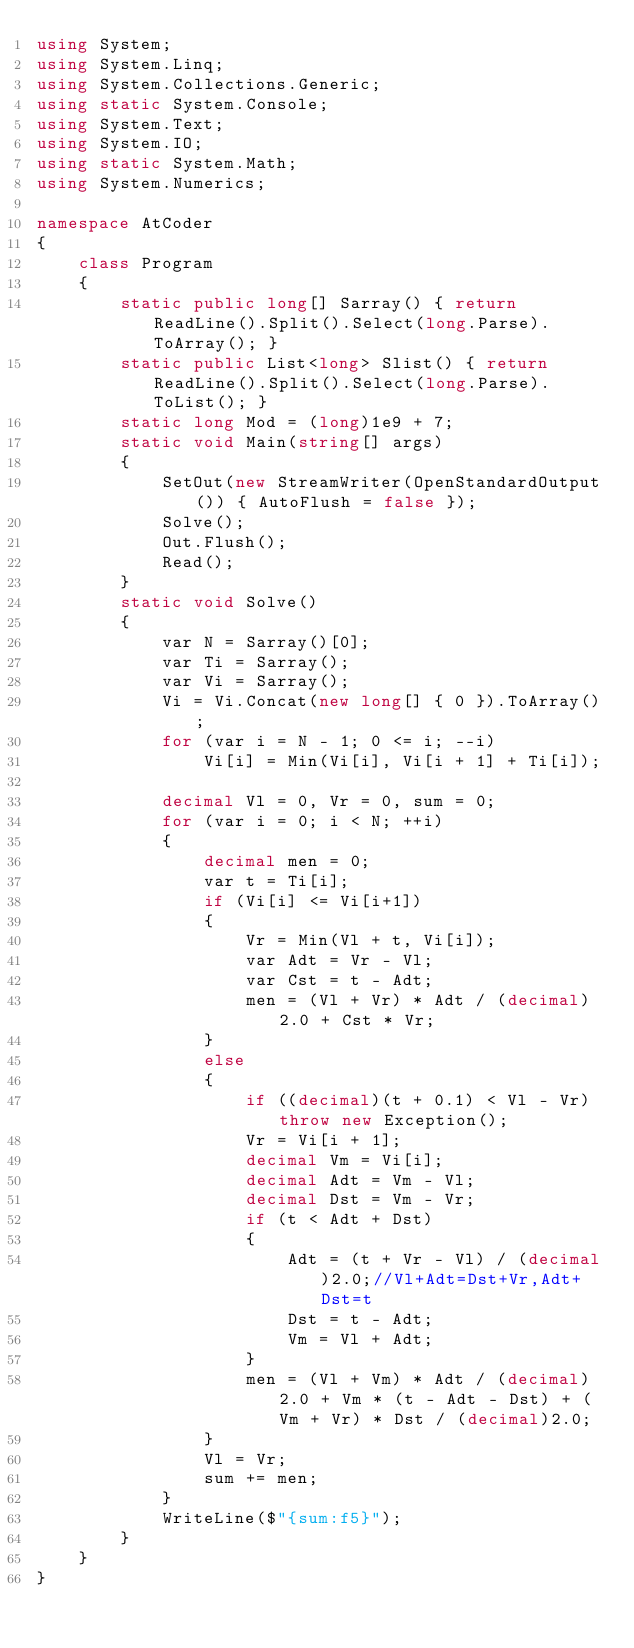<code> <loc_0><loc_0><loc_500><loc_500><_C#_>using System;
using System.Linq;
using System.Collections.Generic;
using static System.Console;
using System.Text;
using System.IO;
using static System.Math;
using System.Numerics;

namespace AtCoder
{
    class Program
    {
        static public long[] Sarray() { return ReadLine().Split().Select(long.Parse).ToArray(); }
        static public List<long> Slist() { return ReadLine().Split().Select(long.Parse).ToList(); }
        static long Mod = (long)1e9 + 7;
        static void Main(string[] args)
        {
            SetOut(new StreamWriter(OpenStandardOutput()) { AutoFlush = false });
            Solve();
            Out.Flush();
            Read();
        }
        static void Solve()
        {
            var N = Sarray()[0];
            var Ti = Sarray();
            var Vi = Sarray();
            Vi = Vi.Concat(new long[] { 0 }).ToArray();
            for (var i = N - 1; 0 <= i; --i)
                Vi[i] = Min(Vi[i], Vi[i + 1] + Ti[i]);

            decimal Vl = 0, Vr = 0, sum = 0;
            for (var i = 0; i < N; ++i)
            {
                decimal men = 0;
                var t = Ti[i];
                if (Vi[i] <= Vi[i+1])
                {
                    Vr = Min(Vl + t, Vi[i]);
                    var Adt = Vr - Vl;
                    var Cst = t - Adt;
                    men = (Vl + Vr) * Adt / (decimal)2.0 + Cst * Vr;
                }
                else
                {
                    if ((decimal)(t + 0.1) < Vl - Vr) throw new Exception();
                    Vr = Vi[i + 1];
                    decimal Vm = Vi[i];
                    decimal Adt = Vm - Vl;
                    decimal Dst = Vm - Vr;
                    if (t < Adt + Dst)
                    {
                        Adt = (t + Vr - Vl) / (decimal)2.0;//Vl+Adt=Dst+Vr,Adt+Dst=t
                        Dst = t - Adt;
                        Vm = Vl + Adt;
                    }
                    men = (Vl + Vm) * Adt / (decimal)2.0 + Vm * (t - Adt - Dst) + (Vm + Vr) * Dst / (decimal)2.0;
                }
                Vl = Vr;
                sum += men;
            }
            WriteLine($"{sum:f5}");
        }
    }
}</code> 